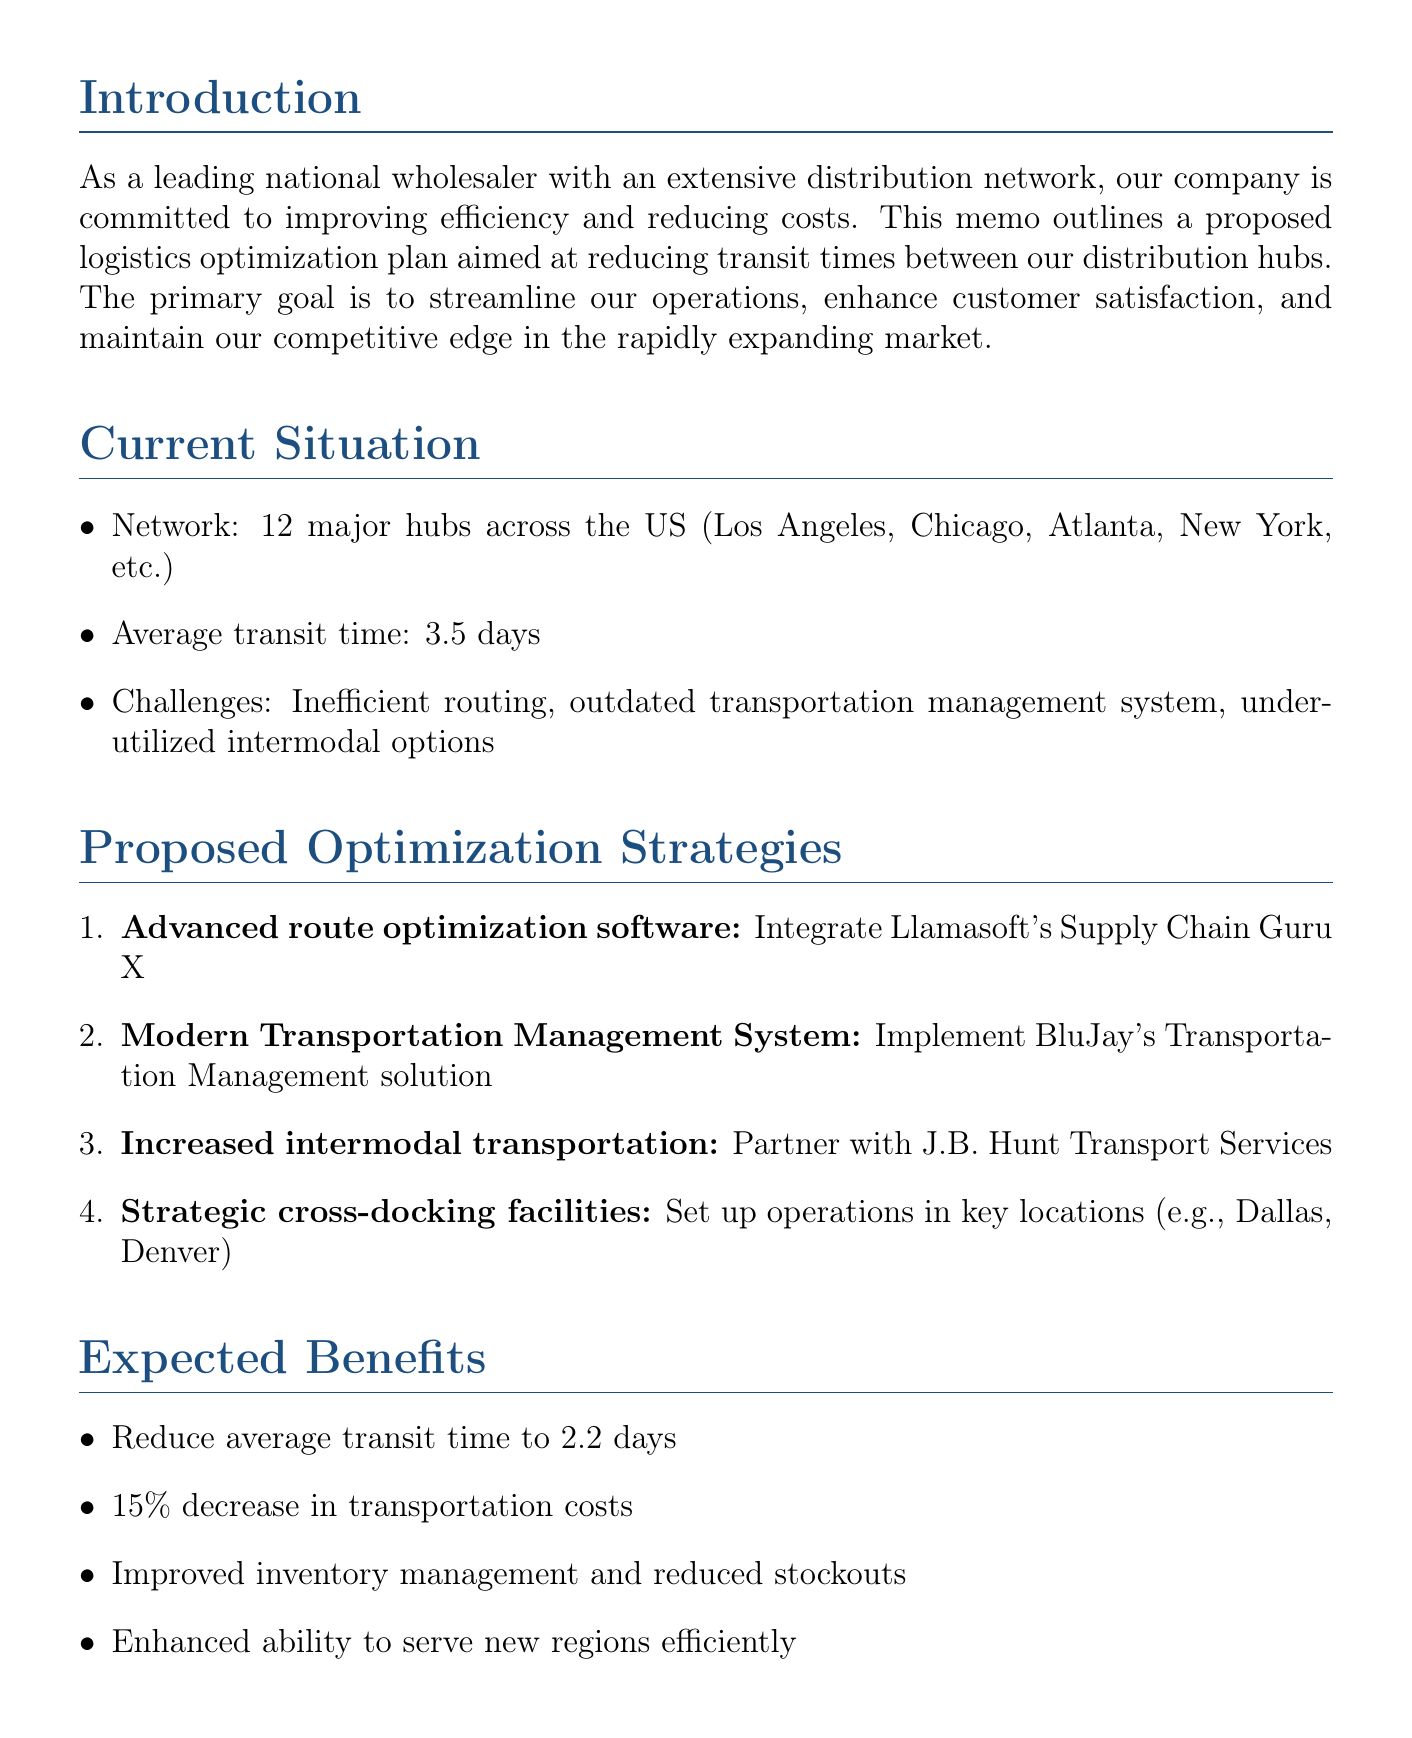what is the title of the memo? The title of the memo is explicitly stated at the beginning of the document.
Answer: Logistics Optimization Plan: Reducing Transit Times Between Distribution Hubs how many major hubs are mentioned? The document provides an overview of the distribution network, specifically noting the number of hubs in operation.
Answer: 12 what is the current average transit time? The document directly states the current average transit time between the hubs.
Answer: 3.5 days which software platform is proposed for route optimization? The document lists the specific software to be integrated for optimization.
Answer: Llamasoft's Supply Chain Guru X how much is the total estimated cost? The total estimated cost for the proposed optimization plan is specified in the budget considerations section.
Answer: $4.5 million what is the expected ROI over 3 years? The document outlines the return on investment projected for the proposed plan.
Answer: 150% which city is mentioned for establishing cross-docking facilities? The document specifies certain cities for the setup of cross-docking operations.
Answer: Dallas how long is the planning and vendor selection phase? The implementation timeline section details the duration of each phase.
Answer: 2 months what is one of the challenges faced in the current situation? The document lists challenges in the current logistics situation under the current situation section.
Answer: Inefficient routing 